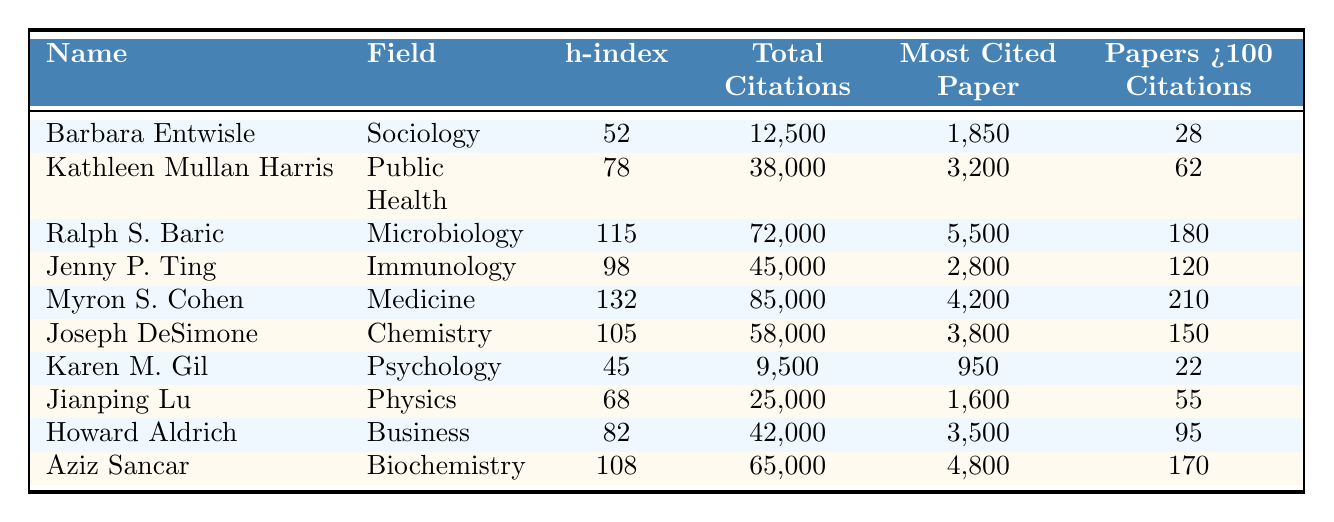What is the highest h-index among the researchers? The h-index is a measure of both the productivity and citation impact of a researcher. By reviewing the h-index values in the table, we see that Myron S. Cohen has the highest h-index at 132.
Answer: 132 Which researcher has the most total citations? By comparing the total citations of each researcher in the table, Myron S. Cohen has the most total citations with 85,000.
Answer: 85,000 How many researchers have an h-index greater than 100? In the table, we count the researchers with an h-index greater than 100: Ralph S. Baric (115), Myron S. Cohen (132), Joseph DeSimone (105), and Aziz Sancar (108). This gives us a total of four researchers.
Answer: 4 What is the average total citations for the researchers in the field of Public Health? The only researcher in the field of Public Health is Kathleen Mullan Harris, who has a total of 38,000 citations. Since there’s only one researcher, the average total citations are the same as her total.
Answer: 38,000 Is it true that all researchers in the table have at least one paper cited over 1,000 times? Looking at the "most cited paper" column for each researcher, we find that all researchers have a most cited paper with citation counts above 1,000.
Answer: Yes What is the total number of papers with over 100 citations across all researchers? We gather the number of papers with over 100 citations from each researcher and sum them: 28 + 62 + 180 + 120 + 210 + 150 + 22 + 55 + 95 + 170 = 1,062.
Answer: 1,062 Which researcher in Microbiology has the highest number of papers with over 100 citations? The researcher Ralph S. Baric in Microbiology has the highest number with 180 papers cited over 100 times.
Answer: Ralph S. Baric What is the difference in total citations between the top researcher in Medicine and the top researcher in Chemistry? The top researcher in Medicine is Myron S. Cohen with 85,000 citations, and in Chemistry, it’s Joseph DeSimone with 58,000 citations. The difference is 85,000 - 58,000 = 27,000.
Answer: 27,000 How many different fields are represented by the researchers in the table? Counting the unique fields listed we find: Sociology, Public Health, Microbiology, Immunology, Medicine, Chemistry, Psychology, Physics, Business, and Biochemistry, making a total of ten distinct fields.
Answer: 10 Who has the least total citations among the researchers listed? Looking at the total citations, Karen M. Gil in Psychology has the least total citations with 9,500.
Answer: 9,500 